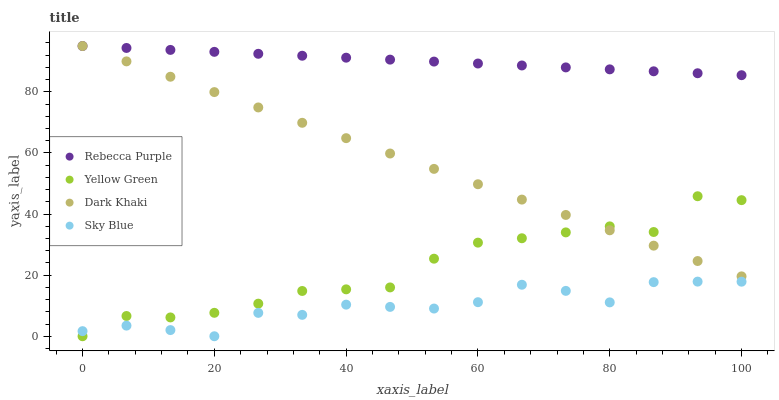Does Sky Blue have the minimum area under the curve?
Answer yes or no. Yes. Does Rebecca Purple have the maximum area under the curve?
Answer yes or no. Yes. Does Rebecca Purple have the minimum area under the curve?
Answer yes or no. No. Does Sky Blue have the maximum area under the curve?
Answer yes or no. No. Is Rebecca Purple the smoothest?
Answer yes or no. Yes. Is Yellow Green the roughest?
Answer yes or no. Yes. Is Sky Blue the smoothest?
Answer yes or no. No. Is Sky Blue the roughest?
Answer yes or no. No. Does Sky Blue have the lowest value?
Answer yes or no. Yes. Does Rebecca Purple have the lowest value?
Answer yes or no. No. Does Rebecca Purple have the highest value?
Answer yes or no. Yes. Does Sky Blue have the highest value?
Answer yes or no. No. Is Sky Blue less than Rebecca Purple?
Answer yes or no. Yes. Is Rebecca Purple greater than Sky Blue?
Answer yes or no. Yes. Does Dark Khaki intersect Rebecca Purple?
Answer yes or no. Yes. Is Dark Khaki less than Rebecca Purple?
Answer yes or no. No. Is Dark Khaki greater than Rebecca Purple?
Answer yes or no. No. Does Sky Blue intersect Rebecca Purple?
Answer yes or no. No. 